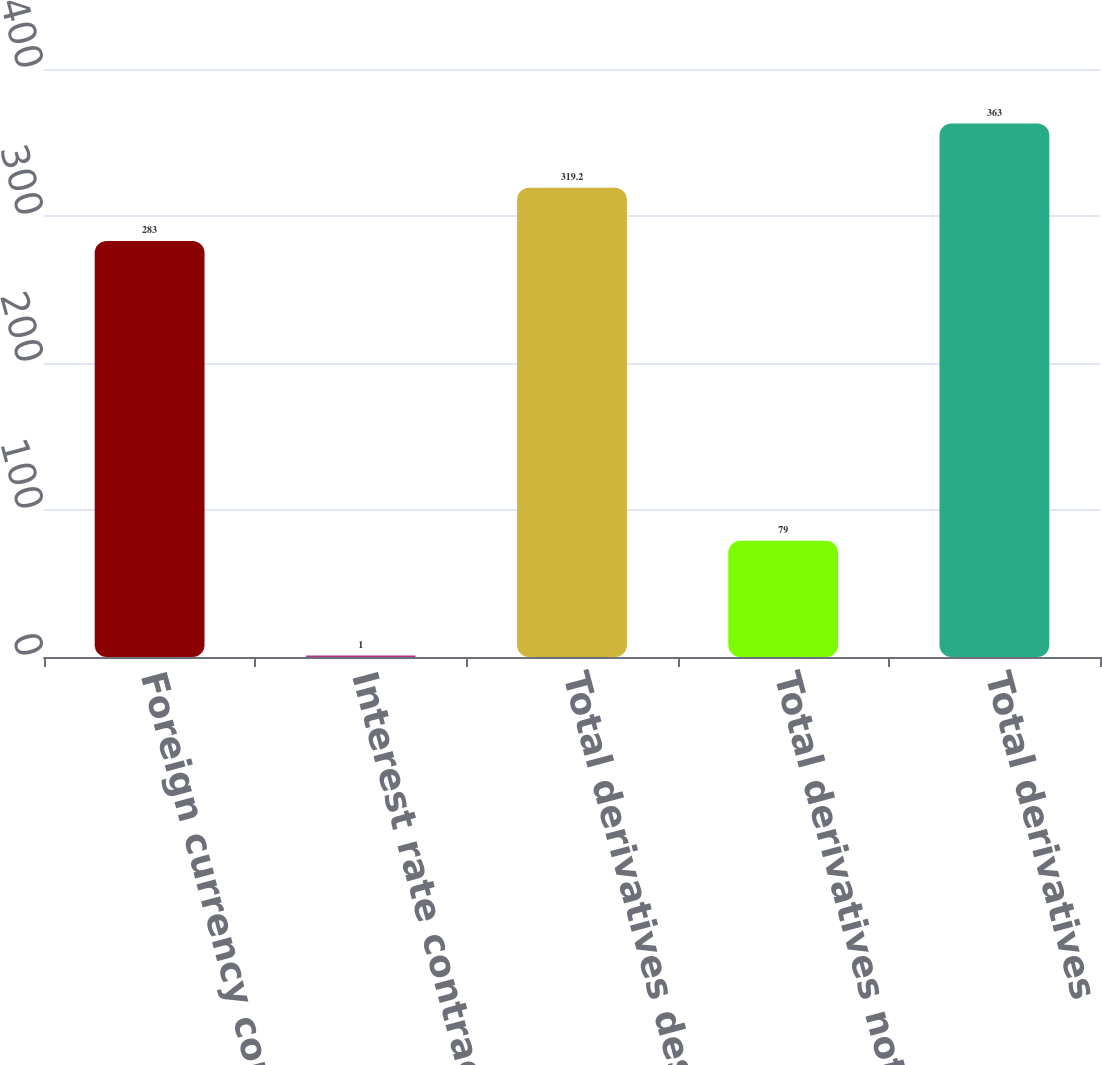Convert chart to OTSL. <chart><loc_0><loc_0><loc_500><loc_500><bar_chart><fcel>Foreign currency contracts 3<fcel>Interest rate contracts<fcel>Total derivatives designated<fcel>Total derivatives not<fcel>Total derivatives<nl><fcel>283<fcel>1<fcel>319.2<fcel>79<fcel>363<nl></chart> 